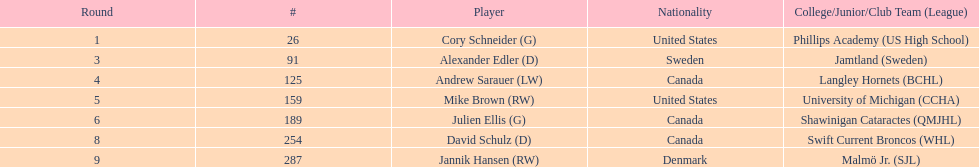How many goalie picks? 2. 